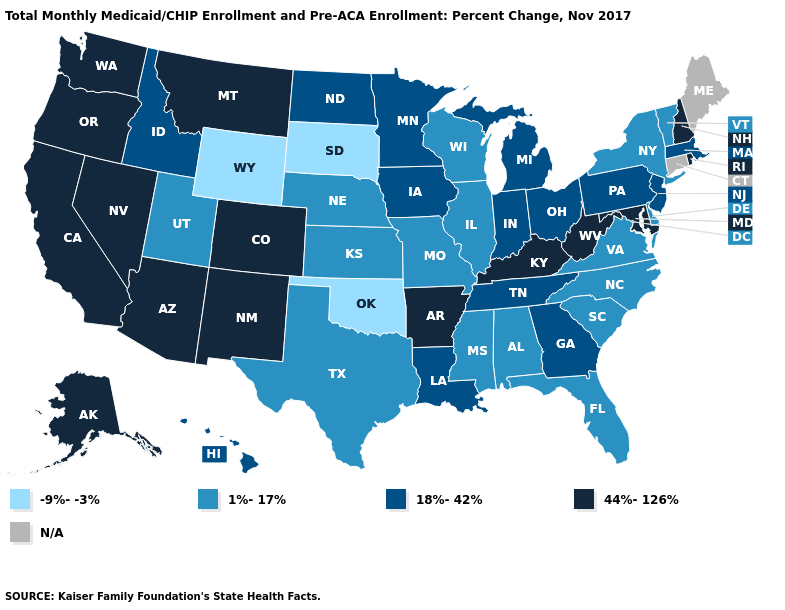Which states have the lowest value in the West?
Short answer required. Wyoming. Which states have the lowest value in the USA?
Answer briefly. Oklahoma, South Dakota, Wyoming. Name the states that have a value in the range 1%-17%?
Answer briefly. Alabama, Delaware, Florida, Illinois, Kansas, Mississippi, Missouri, Nebraska, New York, North Carolina, South Carolina, Texas, Utah, Vermont, Virginia, Wisconsin. Name the states that have a value in the range 44%-126%?
Keep it brief. Alaska, Arizona, Arkansas, California, Colorado, Kentucky, Maryland, Montana, Nevada, New Hampshire, New Mexico, Oregon, Rhode Island, Washington, West Virginia. What is the highest value in states that border New Jersey?
Quick response, please. 18%-42%. What is the value of Mississippi?
Be succinct. 1%-17%. Which states have the lowest value in the South?
Keep it brief. Oklahoma. What is the value of Wyoming?
Keep it brief. -9%--3%. Does Louisiana have the highest value in the South?
Keep it brief. No. What is the lowest value in states that border Alabama?
Short answer required. 1%-17%. What is the value of Kentucky?
Write a very short answer. 44%-126%. What is the lowest value in the West?
Short answer required. -9%--3%. What is the highest value in the USA?
Answer briefly. 44%-126%. 